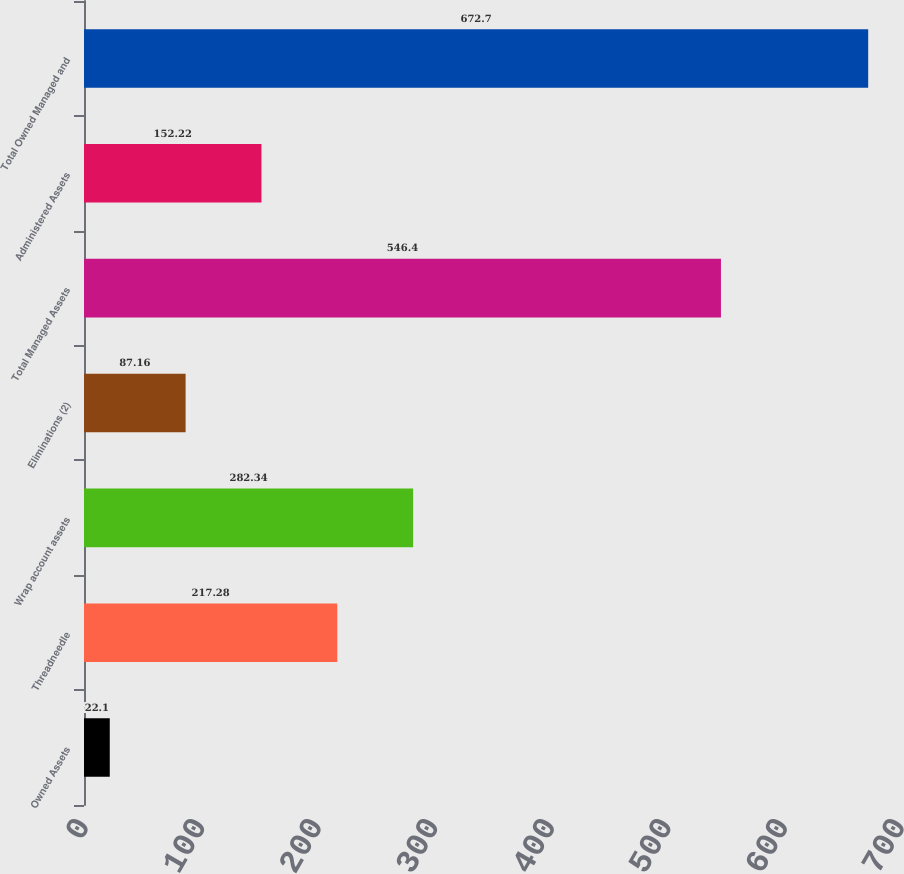Convert chart. <chart><loc_0><loc_0><loc_500><loc_500><bar_chart><fcel>Owned Assets<fcel>Threadneedle<fcel>Wrap account assets<fcel>Eliminations (2)<fcel>Total Managed Assets<fcel>Administered Assets<fcel>Total Owned Managed and<nl><fcel>22.1<fcel>217.28<fcel>282.34<fcel>87.16<fcel>546.4<fcel>152.22<fcel>672.7<nl></chart> 